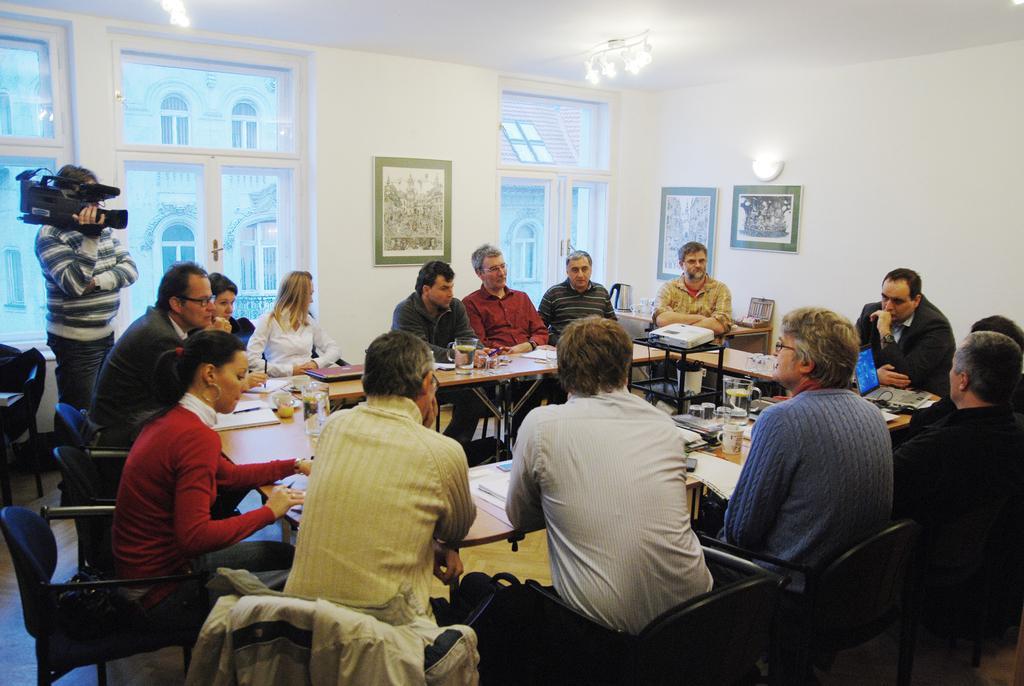Could you give a brief overview of what you see in this image? In this picture we can see a group of people sitting on chairs and here man standing holding camera in his hand and in front of them there is table and on table we can see glass, laptop, jar, projector, papers and in background we can see wall with frame, lights, window. 